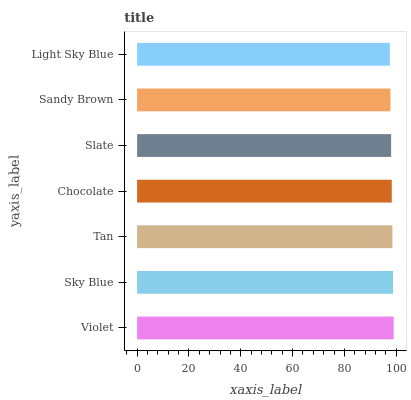Is Light Sky Blue the minimum?
Answer yes or no. Yes. Is Violet the maximum?
Answer yes or no. Yes. Is Sky Blue the minimum?
Answer yes or no. No. Is Sky Blue the maximum?
Answer yes or no. No. Is Violet greater than Sky Blue?
Answer yes or no. Yes. Is Sky Blue less than Violet?
Answer yes or no. Yes. Is Sky Blue greater than Violet?
Answer yes or no. No. Is Violet less than Sky Blue?
Answer yes or no. No. Is Chocolate the high median?
Answer yes or no. Yes. Is Chocolate the low median?
Answer yes or no. Yes. Is Slate the high median?
Answer yes or no. No. Is Light Sky Blue the low median?
Answer yes or no. No. 